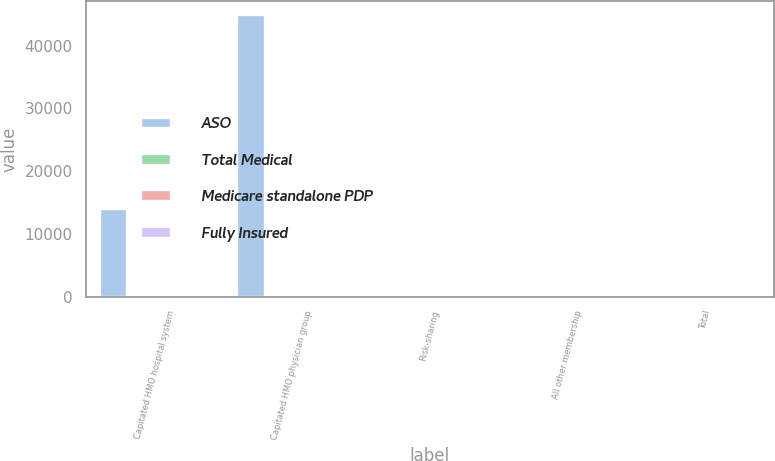<chart> <loc_0><loc_0><loc_500><loc_500><stacked_bar_chart><ecel><fcel>Capitated HMO hospital system<fcel>Capitated HMO physician group<fcel>Risk-sharing<fcel>All other membership<fcel>Total<nl><fcel>ASO<fcel>13900<fcel>44800<fcel>78.4<fcel>78.4<fcel>100<nl><fcel>Total Medical<fcel>0<fcel>0<fcel>0<fcel>100<fcel>100<nl><fcel>Medicare standalone PDP<fcel>0<fcel>0<fcel>0<fcel>100<fcel>100<nl><fcel>Fully Insured<fcel>0<fcel>0<fcel>0<fcel>100<fcel>100<nl></chart> 